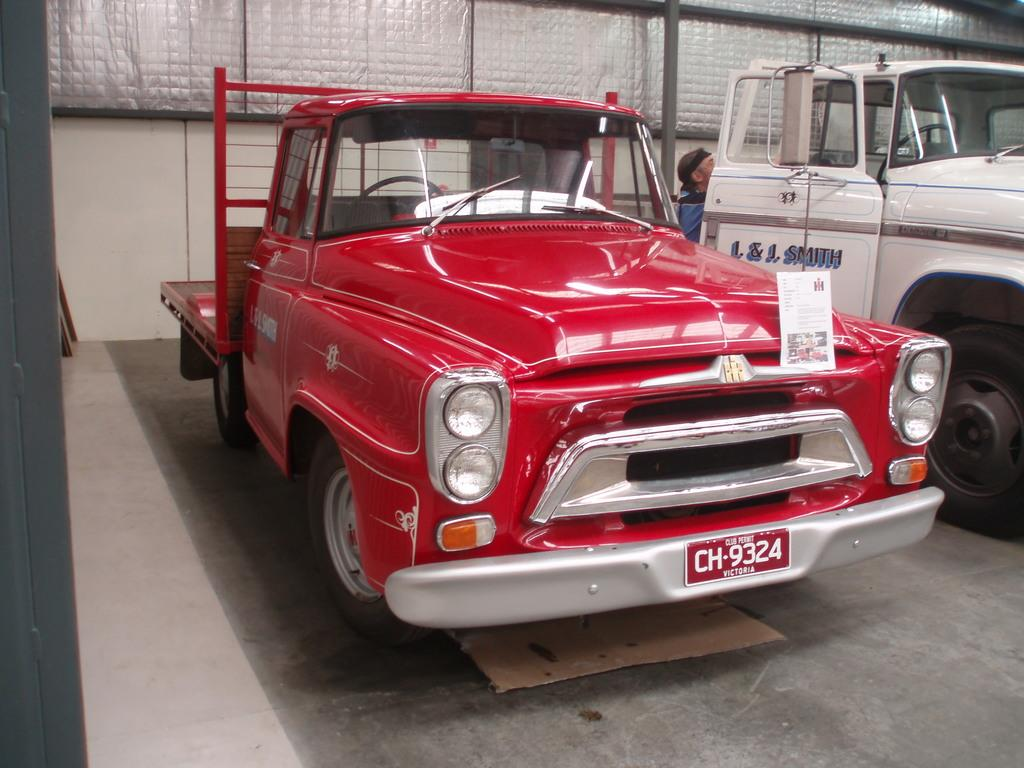What can be seen on the path in the image? There are vehicles parked on the path in the image. What is located behind the vehicles? There are people behind the vehicles. What is visible behind the people? There is a wall behind the people. What type of material is present in the image? Iron rods are present in the image. What type of fish can be seen swimming near the vehicles in the image? There are no fish present in the image; it features vehicles parked on a path with people and a wall behind them. How does the minister interact with the iron rods in the image? There is no minister present in the image, and therefore no interaction with the iron rods can be observed. 